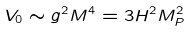<formula> <loc_0><loc_0><loc_500><loc_500>V _ { 0 } \sim g ^ { 2 } M ^ { 4 } = 3 H ^ { 2 } M _ { P } ^ { 2 }</formula> 